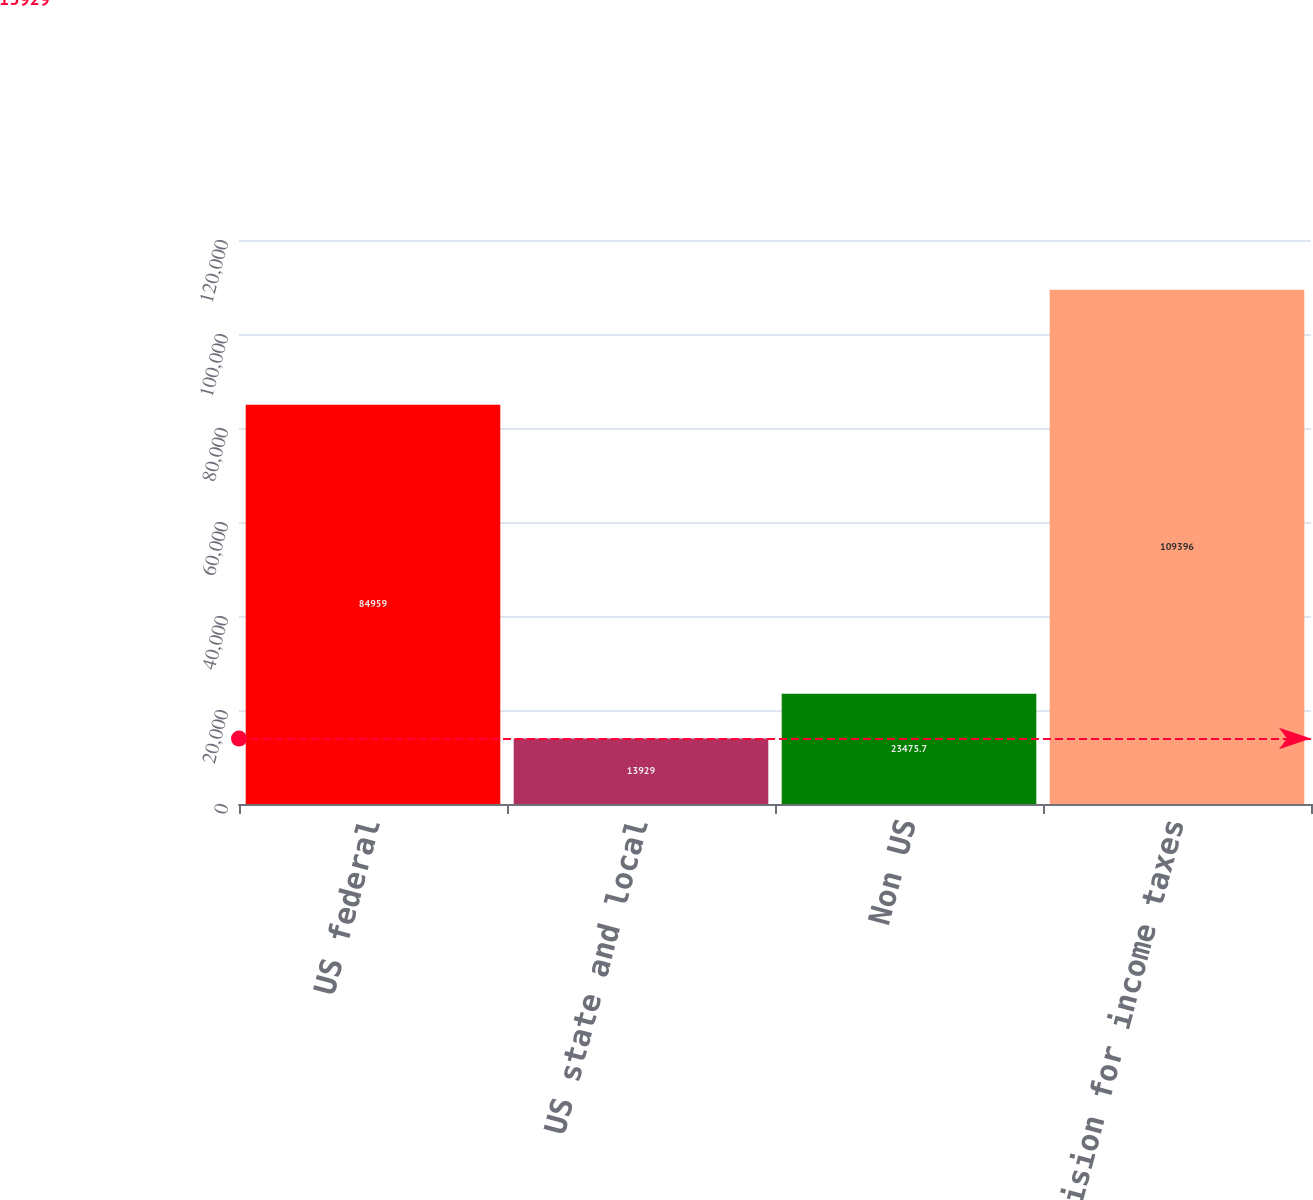Convert chart. <chart><loc_0><loc_0><loc_500><loc_500><bar_chart><fcel>US federal<fcel>US state and local<fcel>Non US<fcel>Provision for income taxes<nl><fcel>84959<fcel>13929<fcel>23475.7<fcel>109396<nl></chart> 